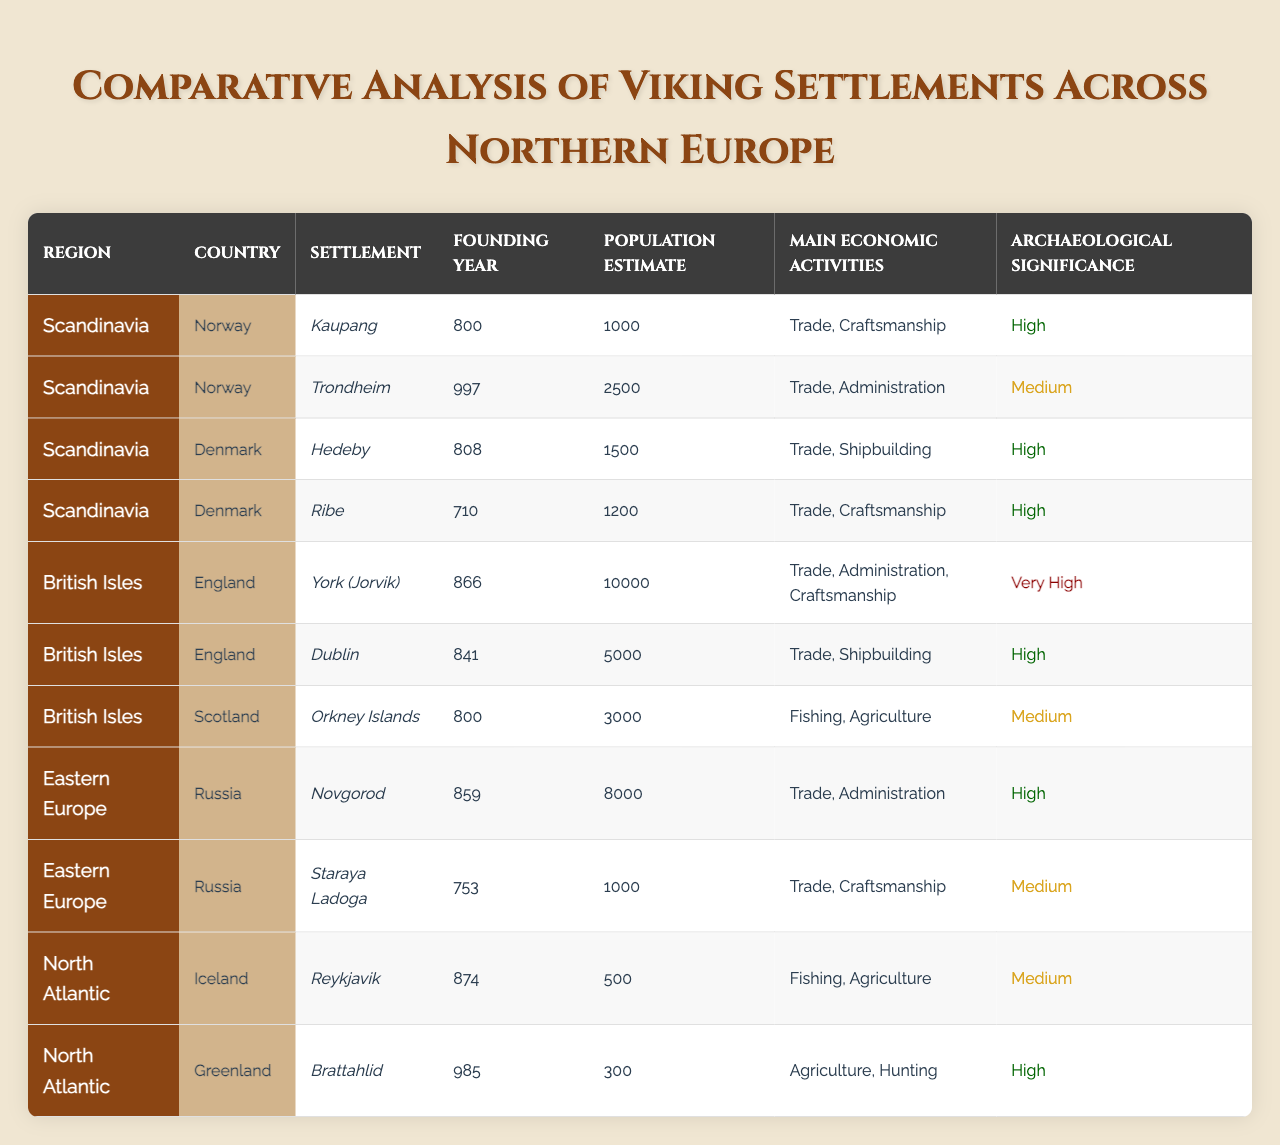What is the founding year of the settlement Hedeby? The table shows that the founding year for Hedeby, which is in Denmark, is listed as 808.
Answer: 808 Which settlement in the British Isles has the highest population estimate? Upon reviewing the table, York (Jorvik) in England has the highest population estimate with a value of 10,000.
Answer: 10,000 How many settlements in Norway are documented in the table? The table lists two settlements in Norway: Kaupang and Trondheim. Thus, the total count is 2.
Answer: 2 What are the main economic activities of the settlement Brattahlid in Greenland? According to the table, the main economic activities of Brattahlid are agriculture and hunting.
Answer: Agriculture and hunting Which Viking settlement has Very High archaeological significance? The table indicates that York (Jorvik) in England is the only settlement with Very High archaeological significance.
Answer: York (Jorvik) What is the average population estimate of the settlements in the North Atlantic region? The table provides the population estimates for Reykjavik (500) and Brattahlid (300). The average is calculated as (500 + 300) / 2 = 400.
Answer: 400 Is there a settlement in Scotland, and if so, what is its archaeological significance? Yes, there is one settlement in Scotland, which is the Orkney Islands, and its archaeological significance is Medium according to the table.
Answer: Yes, Medium Which country has the settlement with the earliest founding year among all listed? By inspecting the founding years across the table, the earliest founding year is 753 for Staraya Ladoga in Russia.
Answer: Staraya Ladoga What is the sum of the population estimates of all settlements in Denmark? The table shows that the population estimates for Hedeby and Ribe are 1500 and 1200, respectively. The sum is calculated as 1500 + 1200 = 2700.
Answer: 2700 Which region has the largest population sum of its settlements? The British Isles region, consisting of York (10,000) and Dublin (5,000), has the largest sum of 15,000 compared to other regions.
Answer: British Isles How does the archaeological significance of Trondheim compare to that of Novgorod? The table assigns Medium archaeological significance to Trondheim and High to Novgorod, making Novgorod's significance higher.
Answer: Novgorod is higher 